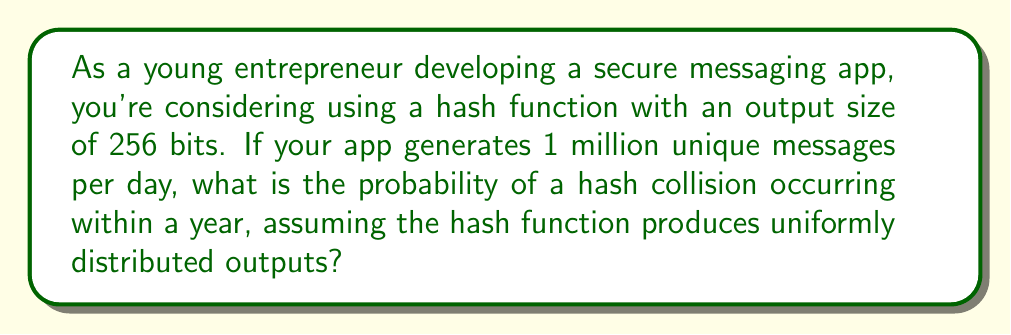Provide a solution to this math problem. Let's approach this step-by-step:

1) First, we need to calculate the total number of messages in a year:
   $$365 \text{ days} \times 1,000,000 \text{ messages/day} = 365,000,000 \text{ messages}$$

2) The probability of a collision is related to the "Birthday Problem". We can use the approximation:
   $$P(\text{collision}) \approx 1 - e^{-k^2/(2n)}$$
   where $k$ is the number of messages and $n$ is the number of possible hash values.

3) In this case:
   $k = 365,000,000$
   $n = 2^{256}$ (as the hash function has an output size of 256 bits)

4) Substituting these values:
   $$P(\text{collision}) \approx 1 - e^{-(365,000,000)^2/(2 \times 2^{256})}$$

5) Simplifying:
   $$P(\text{collision}) \approx 1 - e^{-6.64 \times 10^{-62}}$$

6) Using the approximation $e^x \approx 1 + x$ for small $x$:
   $$P(\text{collision}) \approx 1 - (1 - 6.64 \times 10^{-62}) = 6.64 \times 10^{-62}$$
Answer: $6.64 \times 10^{-62}$ 